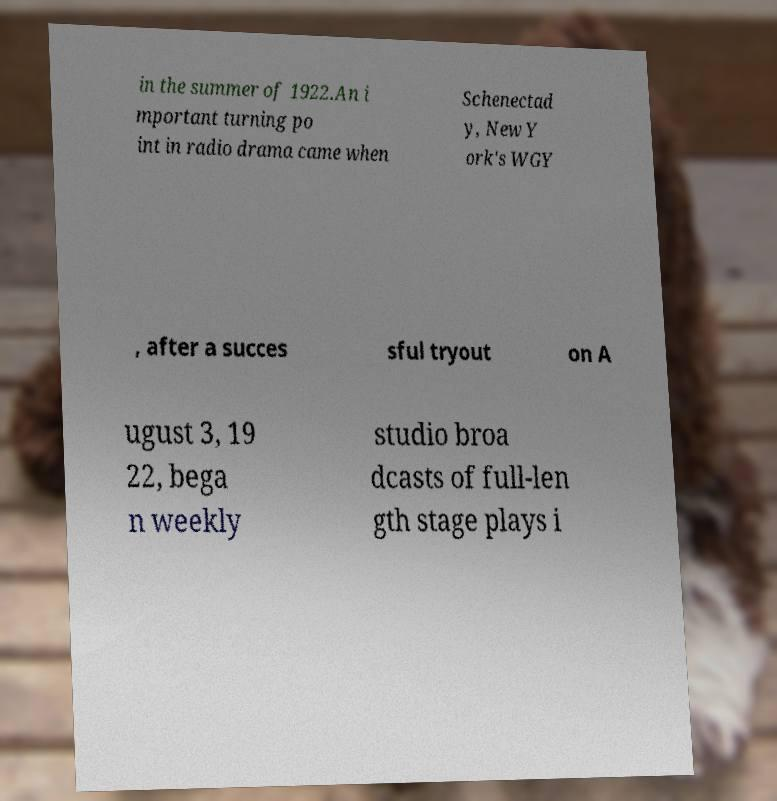Could you assist in decoding the text presented in this image and type it out clearly? in the summer of 1922.An i mportant turning po int in radio drama came when Schenectad y, New Y ork's WGY , after a succes sful tryout on A ugust 3, 19 22, bega n weekly studio broa dcasts of full-len gth stage plays i 